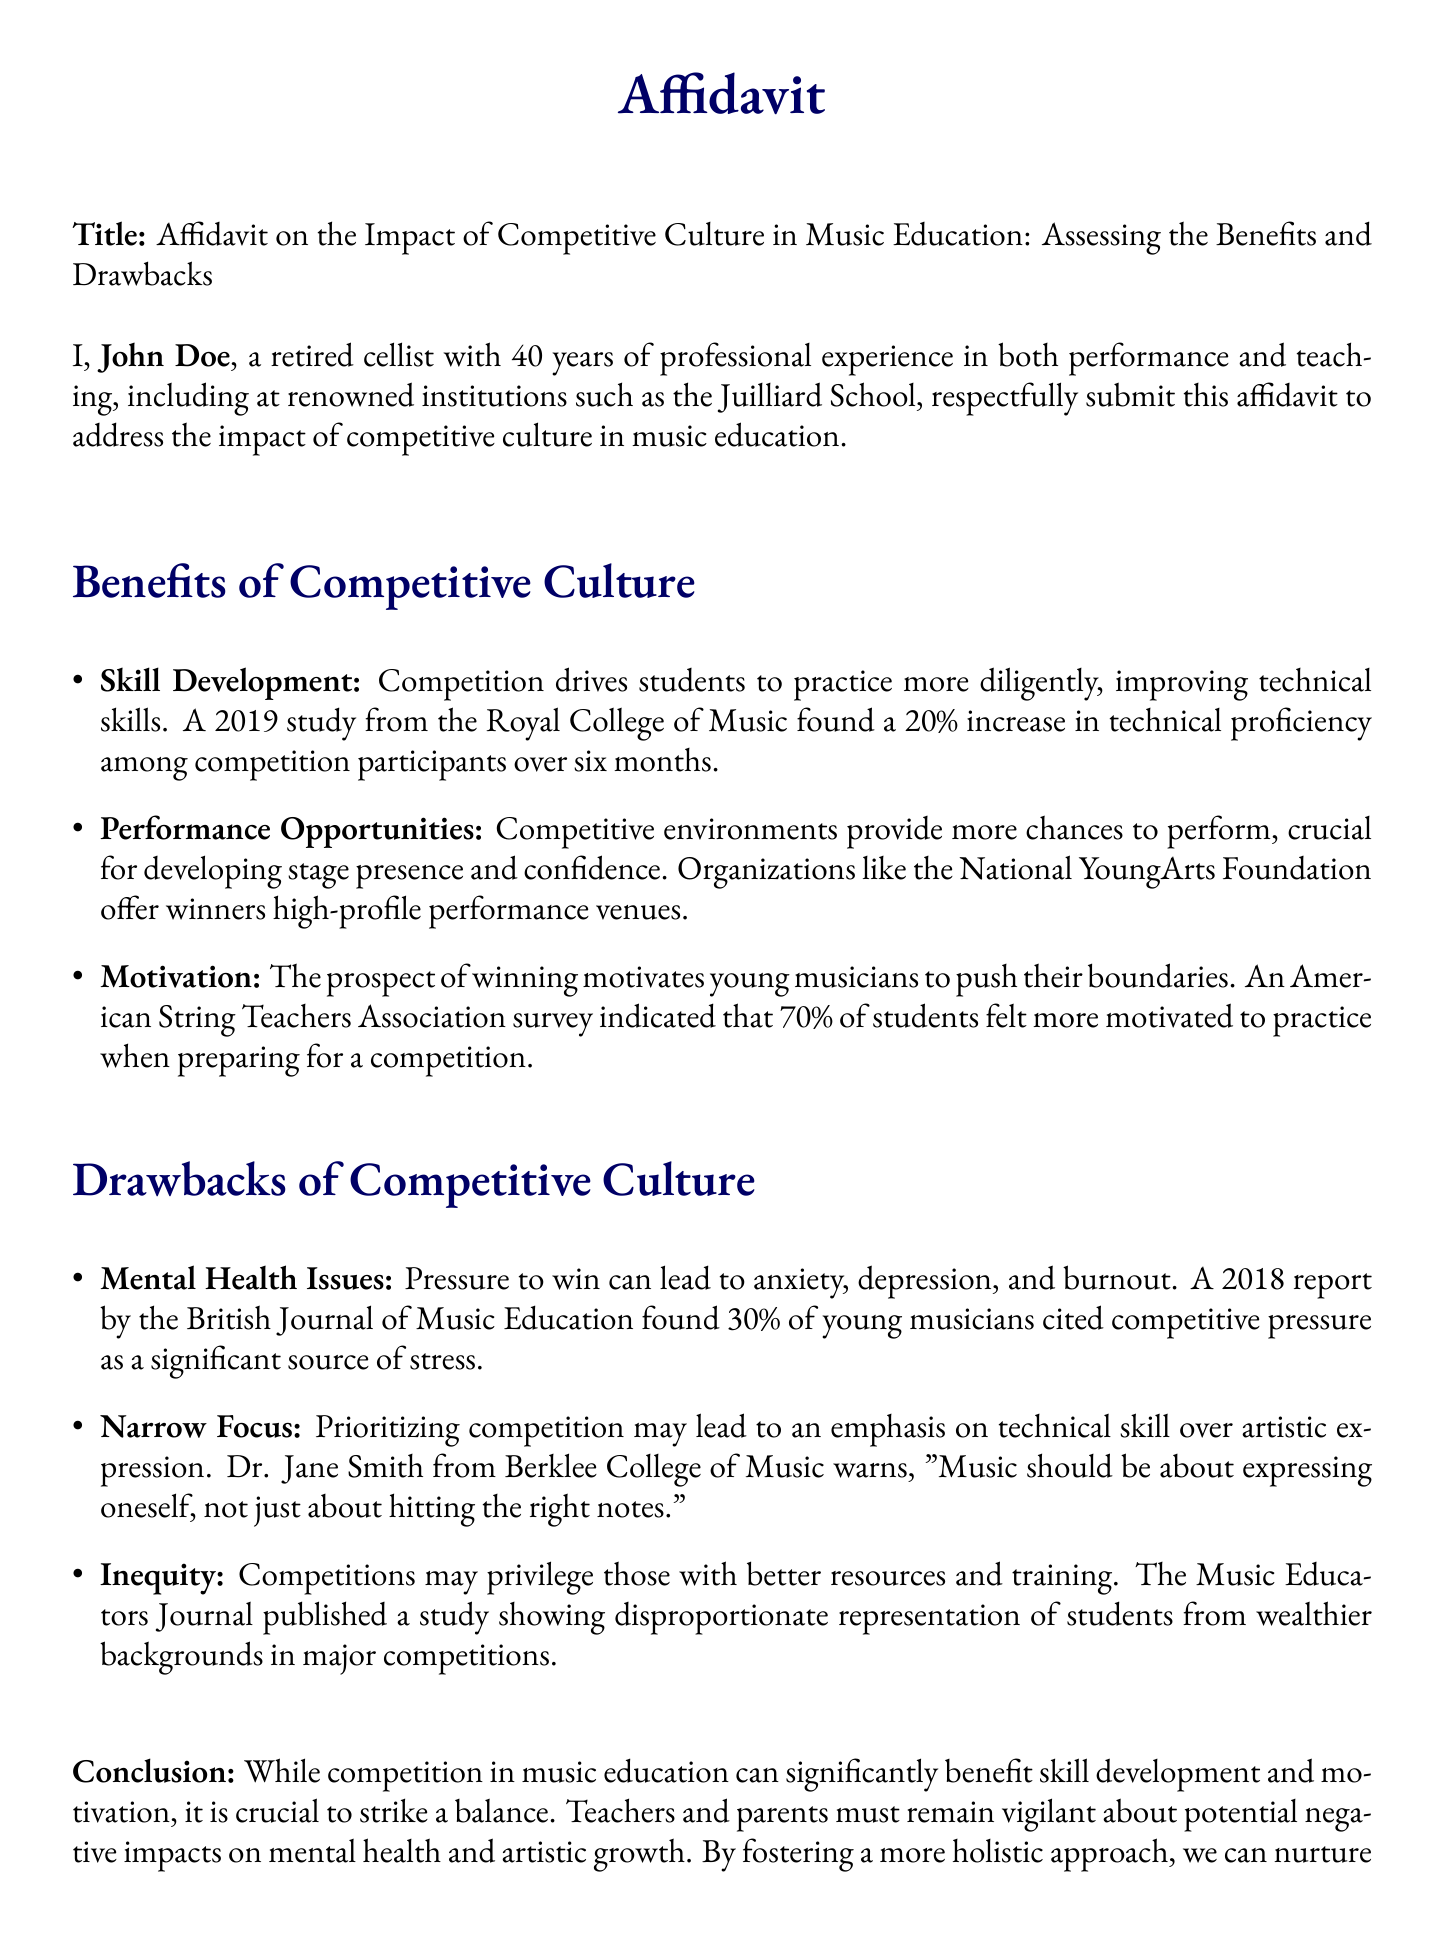what is the name of the author? The affidavit lists the author as John Doe.
Answer: John Doe how many years of experience does John Doe have? The document states that John Doe has 40 years of professional experience.
Answer: 40 years what percentage increase in technical proficiency was observed among competition participants? The document mentions a 20% increase in technical proficiency among competition participants.
Answer: 20% what organization offers high-profile performance venues to winners? The affidavit mentions the National YoungArts Foundation as an organization that offers these opportunities.
Answer: National YoungArts Foundation what percentage of young musicians cited competitive pressure as a significant source of stress? According to a report mentioned, 30% of young musicians cited this issue.
Answer: 30% who warned about the focus on technical skill over artistic expression? The document lists Dr. Jane Smith from Berklee College of Music as issuing this warning.
Answer: Dr. Jane Smith what is the main conclusion of the affidavit? The main conclusion emphasizes the need to strike a balance between competition and its negative impacts.
Answer: Strike a balance what is the impact of competition on motivation according to the American String Teachers Association survey? The survey indicates that 70% of students felt more motivated to practice when preparing for a competition.
Answer: 70% what issue is raised regarding inequity in competitions? The affidavit highlights that competitions may privilege those with better resources and training.
Answer: Privilege those with better resources 